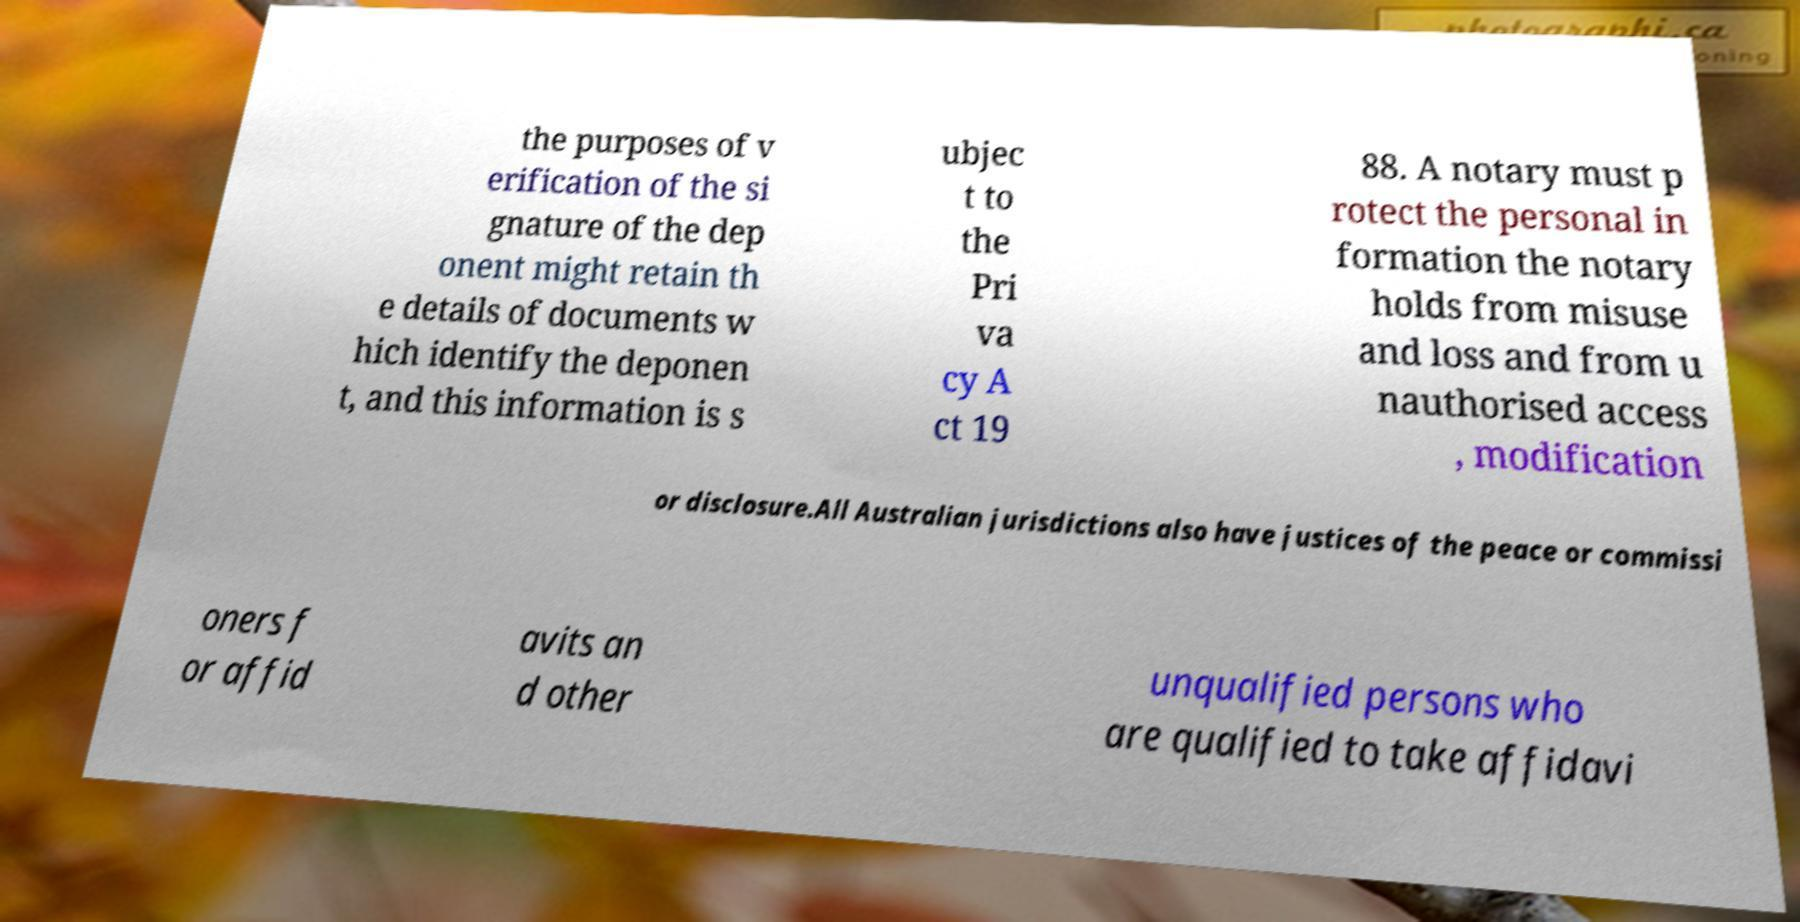I need the written content from this picture converted into text. Can you do that? the purposes of v erification of the si gnature of the dep onent might retain th e details of documents w hich identify the deponen t, and this information is s ubjec t to the Pri va cy A ct 19 88. A notary must p rotect the personal in formation the notary holds from misuse and loss and from u nauthorised access , modification or disclosure.All Australian jurisdictions also have justices of the peace or commissi oners f or affid avits an d other unqualified persons who are qualified to take affidavi 